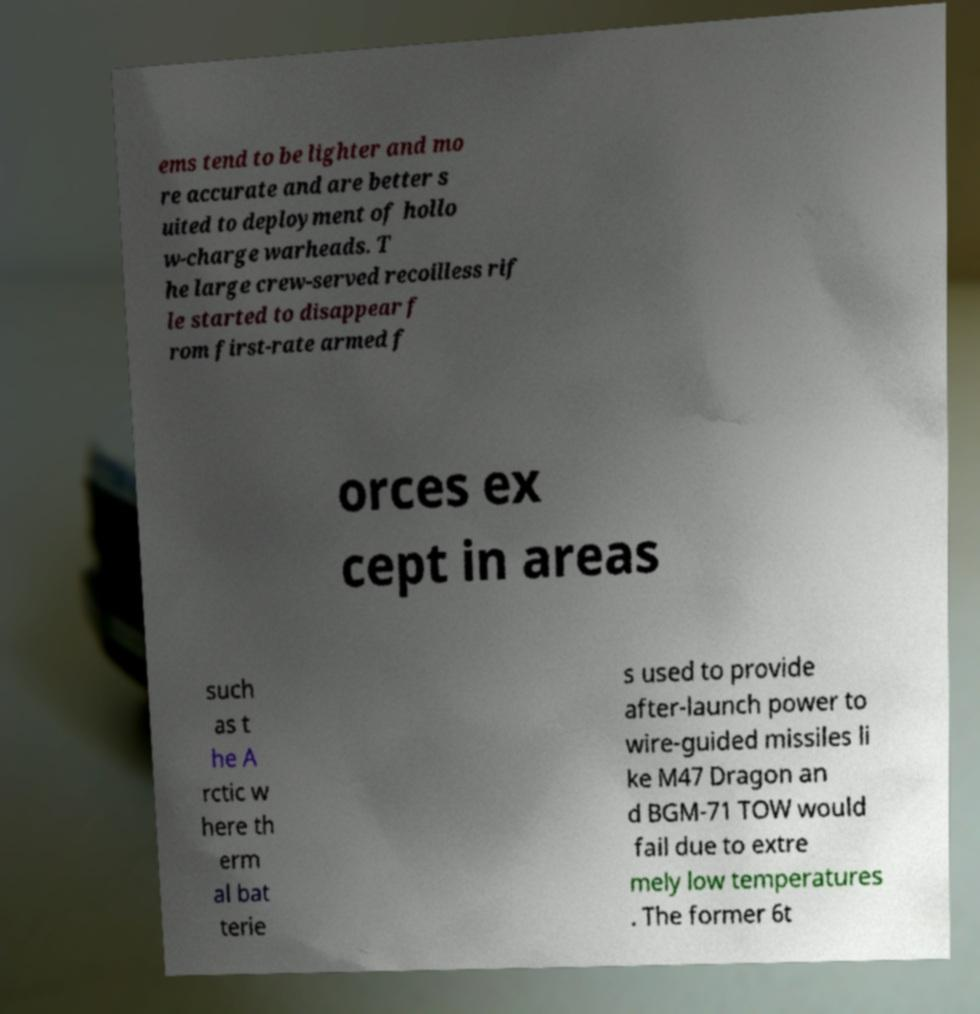Can you read and provide the text displayed in the image?This photo seems to have some interesting text. Can you extract and type it out for me? ems tend to be lighter and mo re accurate and are better s uited to deployment of hollo w-charge warheads. T he large crew-served recoilless rif le started to disappear f rom first-rate armed f orces ex cept in areas such as t he A rctic w here th erm al bat terie s used to provide after-launch power to wire-guided missiles li ke M47 Dragon an d BGM-71 TOW would fail due to extre mely low temperatures . The former 6t 